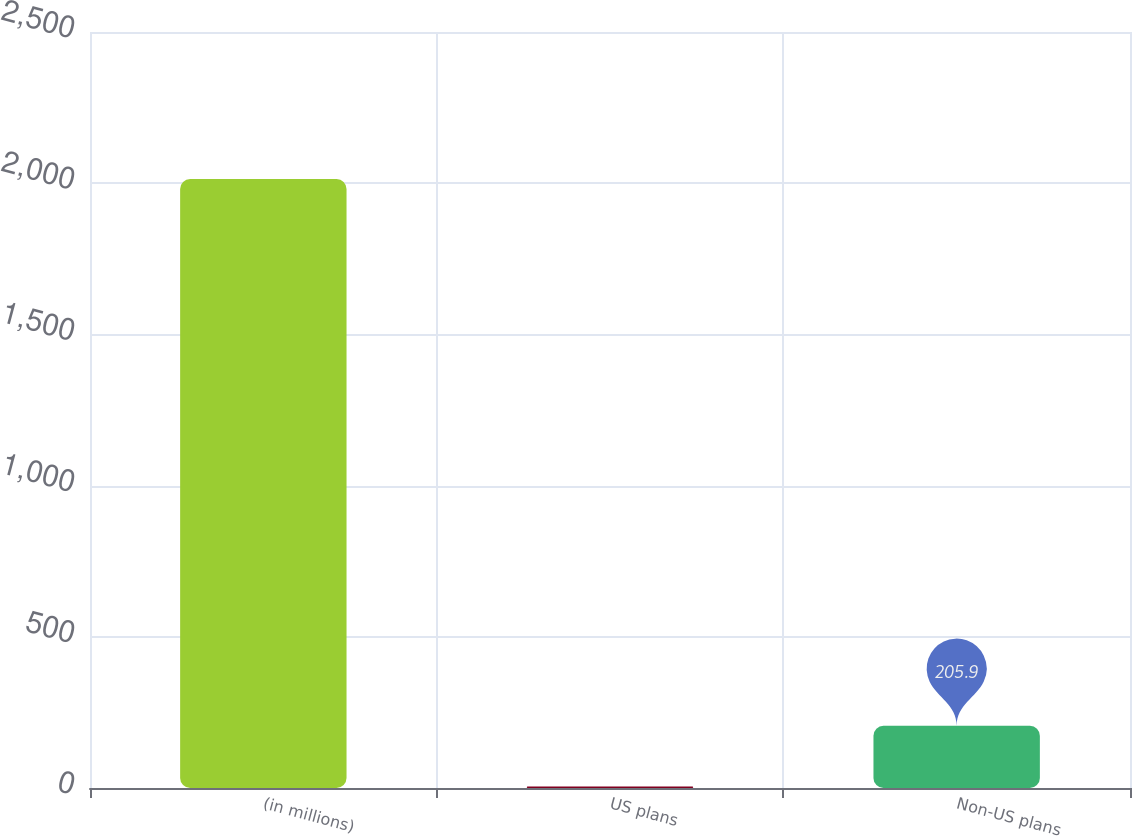<chart> <loc_0><loc_0><loc_500><loc_500><bar_chart><fcel>(in millions)<fcel>US plans<fcel>Non-US plans<nl><fcel>2014<fcel>5<fcel>205.9<nl></chart> 